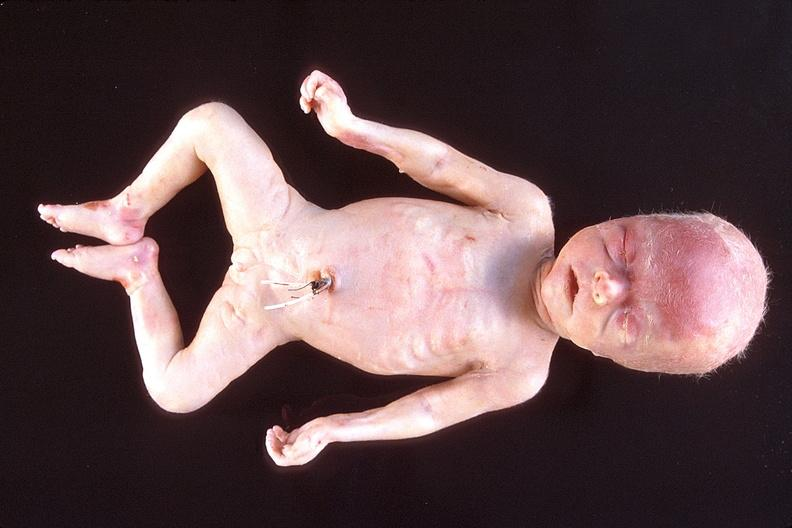does spina bifida show hyaline membrane disease?
Answer the question using a single word or phrase. No 